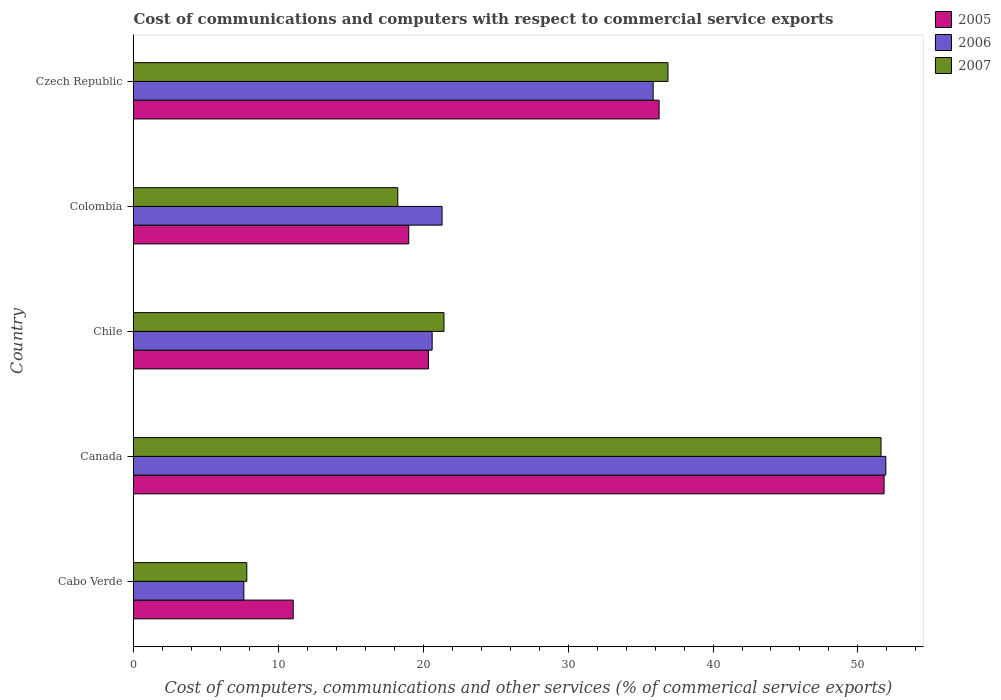How many groups of bars are there?
Offer a terse response. 5. Are the number of bars per tick equal to the number of legend labels?
Your answer should be compact. Yes. Are the number of bars on each tick of the Y-axis equal?
Your response must be concise. Yes. How many bars are there on the 4th tick from the top?
Offer a terse response. 3. How many bars are there on the 2nd tick from the bottom?
Your response must be concise. 3. In how many cases, is the number of bars for a given country not equal to the number of legend labels?
Provide a succinct answer. 0. What is the cost of communications and computers in 2006 in Chile?
Ensure brevity in your answer.  20.61. Across all countries, what is the maximum cost of communications and computers in 2005?
Your answer should be compact. 51.81. Across all countries, what is the minimum cost of communications and computers in 2007?
Offer a very short reply. 7.82. In which country was the cost of communications and computers in 2007 minimum?
Ensure brevity in your answer.  Cabo Verde. What is the total cost of communications and computers in 2005 in the graph?
Offer a terse response. 138.47. What is the difference between the cost of communications and computers in 2005 in Canada and that in Czech Republic?
Provide a succinct answer. 15.53. What is the difference between the cost of communications and computers in 2007 in Chile and the cost of communications and computers in 2005 in Cabo Verde?
Provide a short and direct response. 10.4. What is the average cost of communications and computers in 2005 per country?
Keep it short and to the point. 27.69. What is the difference between the cost of communications and computers in 2006 and cost of communications and computers in 2005 in Colombia?
Your answer should be very brief. 2.3. What is the ratio of the cost of communications and computers in 2007 in Cabo Verde to that in Chile?
Your response must be concise. 0.36. Is the cost of communications and computers in 2005 in Canada less than that in Czech Republic?
Offer a very short reply. No. What is the difference between the highest and the second highest cost of communications and computers in 2007?
Provide a succinct answer. 14.71. What is the difference between the highest and the lowest cost of communications and computers in 2005?
Make the answer very short. 40.78. In how many countries, is the cost of communications and computers in 2006 greater than the average cost of communications and computers in 2006 taken over all countries?
Your answer should be compact. 2. How many bars are there?
Offer a terse response. 15. Are the values on the major ticks of X-axis written in scientific E-notation?
Make the answer very short. No. Does the graph contain any zero values?
Your answer should be very brief. No. Where does the legend appear in the graph?
Ensure brevity in your answer.  Top right. How many legend labels are there?
Ensure brevity in your answer.  3. What is the title of the graph?
Offer a very short reply. Cost of communications and computers with respect to commercial service exports. What is the label or title of the X-axis?
Ensure brevity in your answer.  Cost of computers, communications and other services (% of commerical service exports). What is the Cost of computers, communications and other services (% of commerical service exports) in 2005 in Cabo Verde?
Give a very brief answer. 11.02. What is the Cost of computers, communications and other services (% of commerical service exports) in 2006 in Cabo Verde?
Provide a short and direct response. 7.62. What is the Cost of computers, communications and other services (% of commerical service exports) of 2007 in Cabo Verde?
Keep it short and to the point. 7.82. What is the Cost of computers, communications and other services (% of commerical service exports) of 2005 in Canada?
Give a very brief answer. 51.81. What is the Cost of computers, communications and other services (% of commerical service exports) in 2006 in Canada?
Provide a short and direct response. 51.93. What is the Cost of computers, communications and other services (% of commerical service exports) in 2007 in Canada?
Your answer should be compact. 51.6. What is the Cost of computers, communications and other services (% of commerical service exports) in 2005 in Chile?
Your response must be concise. 20.36. What is the Cost of computers, communications and other services (% of commerical service exports) in 2006 in Chile?
Offer a terse response. 20.61. What is the Cost of computers, communications and other services (% of commerical service exports) of 2007 in Chile?
Your answer should be compact. 21.43. What is the Cost of computers, communications and other services (% of commerical service exports) of 2005 in Colombia?
Your answer should be compact. 19. What is the Cost of computers, communications and other services (% of commerical service exports) of 2006 in Colombia?
Your answer should be compact. 21.3. What is the Cost of computers, communications and other services (% of commerical service exports) of 2007 in Colombia?
Your response must be concise. 18.24. What is the Cost of computers, communications and other services (% of commerical service exports) in 2005 in Czech Republic?
Your answer should be very brief. 36.28. What is the Cost of computers, communications and other services (% of commerical service exports) in 2006 in Czech Republic?
Provide a short and direct response. 35.87. What is the Cost of computers, communications and other services (% of commerical service exports) of 2007 in Czech Republic?
Keep it short and to the point. 36.89. Across all countries, what is the maximum Cost of computers, communications and other services (% of commerical service exports) in 2005?
Offer a terse response. 51.81. Across all countries, what is the maximum Cost of computers, communications and other services (% of commerical service exports) in 2006?
Provide a short and direct response. 51.93. Across all countries, what is the maximum Cost of computers, communications and other services (% of commerical service exports) in 2007?
Offer a terse response. 51.6. Across all countries, what is the minimum Cost of computers, communications and other services (% of commerical service exports) in 2005?
Ensure brevity in your answer.  11.02. Across all countries, what is the minimum Cost of computers, communications and other services (% of commerical service exports) of 2006?
Make the answer very short. 7.62. Across all countries, what is the minimum Cost of computers, communications and other services (% of commerical service exports) in 2007?
Your answer should be compact. 7.82. What is the total Cost of computers, communications and other services (% of commerical service exports) of 2005 in the graph?
Your answer should be compact. 138.47. What is the total Cost of computers, communications and other services (% of commerical service exports) in 2006 in the graph?
Give a very brief answer. 137.32. What is the total Cost of computers, communications and other services (% of commerical service exports) in 2007 in the graph?
Your answer should be very brief. 135.97. What is the difference between the Cost of computers, communications and other services (% of commerical service exports) of 2005 in Cabo Verde and that in Canada?
Ensure brevity in your answer.  -40.78. What is the difference between the Cost of computers, communications and other services (% of commerical service exports) in 2006 in Cabo Verde and that in Canada?
Your answer should be very brief. -44.31. What is the difference between the Cost of computers, communications and other services (% of commerical service exports) in 2007 in Cabo Verde and that in Canada?
Keep it short and to the point. -43.78. What is the difference between the Cost of computers, communications and other services (% of commerical service exports) of 2005 in Cabo Verde and that in Chile?
Keep it short and to the point. -9.33. What is the difference between the Cost of computers, communications and other services (% of commerical service exports) of 2006 in Cabo Verde and that in Chile?
Your answer should be compact. -13. What is the difference between the Cost of computers, communications and other services (% of commerical service exports) of 2007 in Cabo Verde and that in Chile?
Your answer should be very brief. -13.61. What is the difference between the Cost of computers, communications and other services (% of commerical service exports) of 2005 in Cabo Verde and that in Colombia?
Give a very brief answer. -7.97. What is the difference between the Cost of computers, communications and other services (% of commerical service exports) of 2006 in Cabo Verde and that in Colombia?
Offer a terse response. -13.68. What is the difference between the Cost of computers, communications and other services (% of commerical service exports) of 2007 in Cabo Verde and that in Colombia?
Offer a very short reply. -10.42. What is the difference between the Cost of computers, communications and other services (% of commerical service exports) in 2005 in Cabo Verde and that in Czech Republic?
Offer a very short reply. -25.25. What is the difference between the Cost of computers, communications and other services (% of commerical service exports) in 2006 in Cabo Verde and that in Czech Republic?
Keep it short and to the point. -28.25. What is the difference between the Cost of computers, communications and other services (% of commerical service exports) of 2007 in Cabo Verde and that in Czech Republic?
Give a very brief answer. -29.07. What is the difference between the Cost of computers, communications and other services (% of commerical service exports) in 2005 in Canada and that in Chile?
Provide a succinct answer. 31.45. What is the difference between the Cost of computers, communications and other services (% of commerical service exports) of 2006 in Canada and that in Chile?
Offer a very short reply. 31.31. What is the difference between the Cost of computers, communications and other services (% of commerical service exports) in 2007 in Canada and that in Chile?
Ensure brevity in your answer.  30.17. What is the difference between the Cost of computers, communications and other services (% of commerical service exports) of 2005 in Canada and that in Colombia?
Ensure brevity in your answer.  32.81. What is the difference between the Cost of computers, communications and other services (% of commerical service exports) in 2006 in Canada and that in Colombia?
Your answer should be very brief. 30.63. What is the difference between the Cost of computers, communications and other services (% of commerical service exports) in 2007 in Canada and that in Colombia?
Provide a succinct answer. 33.36. What is the difference between the Cost of computers, communications and other services (% of commerical service exports) of 2005 in Canada and that in Czech Republic?
Give a very brief answer. 15.53. What is the difference between the Cost of computers, communications and other services (% of commerical service exports) of 2006 in Canada and that in Czech Republic?
Your response must be concise. 16.06. What is the difference between the Cost of computers, communications and other services (% of commerical service exports) of 2007 in Canada and that in Czech Republic?
Ensure brevity in your answer.  14.71. What is the difference between the Cost of computers, communications and other services (% of commerical service exports) in 2005 in Chile and that in Colombia?
Give a very brief answer. 1.36. What is the difference between the Cost of computers, communications and other services (% of commerical service exports) of 2006 in Chile and that in Colombia?
Your response must be concise. -0.69. What is the difference between the Cost of computers, communications and other services (% of commerical service exports) in 2007 in Chile and that in Colombia?
Provide a short and direct response. 3.19. What is the difference between the Cost of computers, communications and other services (% of commerical service exports) of 2005 in Chile and that in Czech Republic?
Give a very brief answer. -15.92. What is the difference between the Cost of computers, communications and other services (% of commerical service exports) in 2006 in Chile and that in Czech Republic?
Offer a very short reply. -15.25. What is the difference between the Cost of computers, communications and other services (% of commerical service exports) in 2007 in Chile and that in Czech Republic?
Give a very brief answer. -15.46. What is the difference between the Cost of computers, communications and other services (% of commerical service exports) in 2005 in Colombia and that in Czech Republic?
Your answer should be very brief. -17.28. What is the difference between the Cost of computers, communications and other services (% of commerical service exports) in 2006 in Colombia and that in Czech Republic?
Your response must be concise. -14.57. What is the difference between the Cost of computers, communications and other services (% of commerical service exports) in 2007 in Colombia and that in Czech Republic?
Offer a terse response. -18.65. What is the difference between the Cost of computers, communications and other services (% of commerical service exports) in 2005 in Cabo Verde and the Cost of computers, communications and other services (% of commerical service exports) in 2006 in Canada?
Your response must be concise. -40.9. What is the difference between the Cost of computers, communications and other services (% of commerical service exports) of 2005 in Cabo Verde and the Cost of computers, communications and other services (% of commerical service exports) of 2007 in Canada?
Make the answer very short. -40.57. What is the difference between the Cost of computers, communications and other services (% of commerical service exports) in 2006 in Cabo Verde and the Cost of computers, communications and other services (% of commerical service exports) in 2007 in Canada?
Your answer should be compact. -43.98. What is the difference between the Cost of computers, communications and other services (% of commerical service exports) of 2005 in Cabo Verde and the Cost of computers, communications and other services (% of commerical service exports) of 2006 in Chile?
Provide a succinct answer. -9.59. What is the difference between the Cost of computers, communications and other services (% of commerical service exports) in 2005 in Cabo Verde and the Cost of computers, communications and other services (% of commerical service exports) in 2007 in Chile?
Provide a succinct answer. -10.4. What is the difference between the Cost of computers, communications and other services (% of commerical service exports) of 2006 in Cabo Verde and the Cost of computers, communications and other services (% of commerical service exports) of 2007 in Chile?
Keep it short and to the point. -13.81. What is the difference between the Cost of computers, communications and other services (% of commerical service exports) of 2005 in Cabo Verde and the Cost of computers, communications and other services (% of commerical service exports) of 2006 in Colombia?
Offer a very short reply. -10.27. What is the difference between the Cost of computers, communications and other services (% of commerical service exports) in 2005 in Cabo Verde and the Cost of computers, communications and other services (% of commerical service exports) in 2007 in Colombia?
Offer a very short reply. -7.22. What is the difference between the Cost of computers, communications and other services (% of commerical service exports) of 2006 in Cabo Verde and the Cost of computers, communications and other services (% of commerical service exports) of 2007 in Colombia?
Your answer should be very brief. -10.62. What is the difference between the Cost of computers, communications and other services (% of commerical service exports) in 2005 in Cabo Verde and the Cost of computers, communications and other services (% of commerical service exports) in 2006 in Czech Republic?
Ensure brevity in your answer.  -24.84. What is the difference between the Cost of computers, communications and other services (% of commerical service exports) in 2005 in Cabo Verde and the Cost of computers, communications and other services (% of commerical service exports) in 2007 in Czech Republic?
Offer a terse response. -25.86. What is the difference between the Cost of computers, communications and other services (% of commerical service exports) in 2006 in Cabo Verde and the Cost of computers, communications and other services (% of commerical service exports) in 2007 in Czech Republic?
Your answer should be compact. -29.27. What is the difference between the Cost of computers, communications and other services (% of commerical service exports) in 2005 in Canada and the Cost of computers, communications and other services (% of commerical service exports) in 2006 in Chile?
Provide a succinct answer. 31.19. What is the difference between the Cost of computers, communications and other services (% of commerical service exports) of 2005 in Canada and the Cost of computers, communications and other services (% of commerical service exports) of 2007 in Chile?
Ensure brevity in your answer.  30.38. What is the difference between the Cost of computers, communications and other services (% of commerical service exports) in 2006 in Canada and the Cost of computers, communications and other services (% of commerical service exports) in 2007 in Chile?
Offer a terse response. 30.5. What is the difference between the Cost of computers, communications and other services (% of commerical service exports) in 2005 in Canada and the Cost of computers, communications and other services (% of commerical service exports) in 2006 in Colombia?
Provide a short and direct response. 30.51. What is the difference between the Cost of computers, communications and other services (% of commerical service exports) of 2005 in Canada and the Cost of computers, communications and other services (% of commerical service exports) of 2007 in Colombia?
Provide a short and direct response. 33.57. What is the difference between the Cost of computers, communications and other services (% of commerical service exports) of 2006 in Canada and the Cost of computers, communications and other services (% of commerical service exports) of 2007 in Colombia?
Your answer should be very brief. 33.69. What is the difference between the Cost of computers, communications and other services (% of commerical service exports) of 2005 in Canada and the Cost of computers, communications and other services (% of commerical service exports) of 2006 in Czech Republic?
Your answer should be compact. 15.94. What is the difference between the Cost of computers, communications and other services (% of commerical service exports) of 2005 in Canada and the Cost of computers, communications and other services (% of commerical service exports) of 2007 in Czech Republic?
Your answer should be very brief. 14.92. What is the difference between the Cost of computers, communications and other services (% of commerical service exports) in 2006 in Canada and the Cost of computers, communications and other services (% of commerical service exports) in 2007 in Czech Republic?
Make the answer very short. 15.04. What is the difference between the Cost of computers, communications and other services (% of commerical service exports) in 2005 in Chile and the Cost of computers, communications and other services (% of commerical service exports) in 2006 in Colombia?
Make the answer very short. -0.94. What is the difference between the Cost of computers, communications and other services (% of commerical service exports) in 2005 in Chile and the Cost of computers, communications and other services (% of commerical service exports) in 2007 in Colombia?
Your answer should be very brief. 2.12. What is the difference between the Cost of computers, communications and other services (% of commerical service exports) in 2006 in Chile and the Cost of computers, communications and other services (% of commerical service exports) in 2007 in Colombia?
Provide a succinct answer. 2.37. What is the difference between the Cost of computers, communications and other services (% of commerical service exports) in 2005 in Chile and the Cost of computers, communications and other services (% of commerical service exports) in 2006 in Czech Republic?
Keep it short and to the point. -15.51. What is the difference between the Cost of computers, communications and other services (% of commerical service exports) in 2005 in Chile and the Cost of computers, communications and other services (% of commerical service exports) in 2007 in Czech Republic?
Offer a terse response. -16.53. What is the difference between the Cost of computers, communications and other services (% of commerical service exports) of 2006 in Chile and the Cost of computers, communications and other services (% of commerical service exports) of 2007 in Czech Republic?
Make the answer very short. -16.27. What is the difference between the Cost of computers, communications and other services (% of commerical service exports) of 2005 in Colombia and the Cost of computers, communications and other services (% of commerical service exports) of 2006 in Czech Republic?
Your answer should be compact. -16.87. What is the difference between the Cost of computers, communications and other services (% of commerical service exports) in 2005 in Colombia and the Cost of computers, communications and other services (% of commerical service exports) in 2007 in Czech Republic?
Your answer should be very brief. -17.89. What is the difference between the Cost of computers, communications and other services (% of commerical service exports) in 2006 in Colombia and the Cost of computers, communications and other services (% of commerical service exports) in 2007 in Czech Republic?
Provide a succinct answer. -15.59. What is the average Cost of computers, communications and other services (% of commerical service exports) of 2005 per country?
Your response must be concise. 27.69. What is the average Cost of computers, communications and other services (% of commerical service exports) of 2006 per country?
Provide a short and direct response. 27.46. What is the average Cost of computers, communications and other services (% of commerical service exports) of 2007 per country?
Your answer should be very brief. 27.19. What is the difference between the Cost of computers, communications and other services (% of commerical service exports) of 2005 and Cost of computers, communications and other services (% of commerical service exports) of 2006 in Cabo Verde?
Give a very brief answer. 3.41. What is the difference between the Cost of computers, communications and other services (% of commerical service exports) in 2005 and Cost of computers, communications and other services (% of commerical service exports) in 2007 in Cabo Verde?
Offer a terse response. 3.21. What is the difference between the Cost of computers, communications and other services (% of commerical service exports) of 2006 and Cost of computers, communications and other services (% of commerical service exports) of 2007 in Cabo Verde?
Provide a succinct answer. -0.2. What is the difference between the Cost of computers, communications and other services (% of commerical service exports) in 2005 and Cost of computers, communications and other services (% of commerical service exports) in 2006 in Canada?
Offer a very short reply. -0.12. What is the difference between the Cost of computers, communications and other services (% of commerical service exports) in 2005 and Cost of computers, communications and other services (% of commerical service exports) in 2007 in Canada?
Make the answer very short. 0.21. What is the difference between the Cost of computers, communications and other services (% of commerical service exports) in 2006 and Cost of computers, communications and other services (% of commerical service exports) in 2007 in Canada?
Your answer should be very brief. 0.33. What is the difference between the Cost of computers, communications and other services (% of commerical service exports) in 2005 and Cost of computers, communications and other services (% of commerical service exports) in 2006 in Chile?
Give a very brief answer. -0.26. What is the difference between the Cost of computers, communications and other services (% of commerical service exports) of 2005 and Cost of computers, communications and other services (% of commerical service exports) of 2007 in Chile?
Provide a short and direct response. -1.07. What is the difference between the Cost of computers, communications and other services (% of commerical service exports) in 2006 and Cost of computers, communications and other services (% of commerical service exports) in 2007 in Chile?
Provide a succinct answer. -0.81. What is the difference between the Cost of computers, communications and other services (% of commerical service exports) of 2005 and Cost of computers, communications and other services (% of commerical service exports) of 2006 in Colombia?
Your answer should be very brief. -2.3. What is the difference between the Cost of computers, communications and other services (% of commerical service exports) of 2005 and Cost of computers, communications and other services (% of commerical service exports) of 2007 in Colombia?
Ensure brevity in your answer.  0.76. What is the difference between the Cost of computers, communications and other services (% of commerical service exports) in 2006 and Cost of computers, communications and other services (% of commerical service exports) in 2007 in Colombia?
Your answer should be very brief. 3.06. What is the difference between the Cost of computers, communications and other services (% of commerical service exports) of 2005 and Cost of computers, communications and other services (% of commerical service exports) of 2006 in Czech Republic?
Keep it short and to the point. 0.41. What is the difference between the Cost of computers, communications and other services (% of commerical service exports) of 2005 and Cost of computers, communications and other services (% of commerical service exports) of 2007 in Czech Republic?
Keep it short and to the point. -0.61. What is the difference between the Cost of computers, communications and other services (% of commerical service exports) of 2006 and Cost of computers, communications and other services (% of commerical service exports) of 2007 in Czech Republic?
Provide a short and direct response. -1.02. What is the ratio of the Cost of computers, communications and other services (% of commerical service exports) in 2005 in Cabo Verde to that in Canada?
Keep it short and to the point. 0.21. What is the ratio of the Cost of computers, communications and other services (% of commerical service exports) in 2006 in Cabo Verde to that in Canada?
Keep it short and to the point. 0.15. What is the ratio of the Cost of computers, communications and other services (% of commerical service exports) in 2007 in Cabo Verde to that in Canada?
Offer a terse response. 0.15. What is the ratio of the Cost of computers, communications and other services (% of commerical service exports) of 2005 in Cabo Verde to that in Chile?
Keep it short and to the point. 0.54. What is the ratio of the Cost of computers, communications and other services (% of commerical service exports) in 2006 in Cabo Verde to that in Chile?
Keep it short and to the point. 0.37. What is the ratio of the Cost of computers, communications and other services (% of commerical service exports) in 2007 in Cabo Verde to that in Chile?
Keep it short and to the point. 0.36. What is the ratio of the Cost of computers, communications and other services (% of commerical service exports) of 2005 in Cabo Verde to that in Colombia?
Make the answer very short. 0.58. What is the ratio of the Cost of computers, communications and other services (% of commerical service exports) in 2006 in Cabo Verde to that in Colombia?
Ensure brevity in your answer.  0.36. What is the ratio of the Cost of computers, communications and other services (% of commerical service exports) of 2007 in Cabo Verde to that in Colombia?
Give a very brief answer. 0.43. What is the ratio of the Cost of computers, communications and other services (% of commerical service exports) in 2005 in Cabo Verde to that in Czech Republic?
Provide a short and direct response. 0.3. What is the ratio of the Cost of computers, communications and other services (% of commerical service exports) of 2006 in Cabo Verde to that in Czech Republic?
Make the answer very short. 0.21. What is the ratio of the Cost of computers, communications and other services (% of commerical service exports) in 2007 in Cabo Verde to that in Czech Republic?
Give a very brief answer. 0.21. What is the ratio of the Cost of computers, communications and other services (% of commerical service exports) in 2005 in Canada to that in Chile?
Your response must be concise. 2.54. What is the ratio of the Cost of computers, communications and other services (% of commerical service exports) in 2006 in Canada to that in Chile?
Your response must be concise. 2.52. What is the ratio of the Cost of computers, communications and other services (% of commerical service exports) of 2007 in Canada to that in Chile?
Give a very brief answer. 2.41. What is the ratio of the Cost of computers, communications and other services (% of commerical service exports) in 2005 in Canada to that in Colombia?
Keep it short and to the point. 2.73. What is the ratio of the Cost of computers, communications and other services (% of commerical service exports) in 2006 in Canada to that in Colombia?
Your response must be concise. 2.44. What is the ratio of the Cost of computers, communications and other services (% of commerical service exports) in 2007 in Canada to that in Colombia?
Make the answer very short. 2.83. What is the ratio of the Cost of computers, communications and other services (% of commerical service exports) in 2005 in Canada to that in Czech Republic?
Give a very brief answer. 1.43. What is the ratio of the Cost of computers, communications and other services (% of commerical service exports) in 2006 in Canada to that in Czech Republic?
Offer a very short reply. 1.45. What is the ratio of the Cost of computers, communications and other services (% of commerical service exports) of 2007 in Canada to that in Czech Republic?
Your response must be concise. 1.4. What is the ratio of the Cost of computers, communications and other services (% of commerical service exports) of 2005 in Chile to that in Colombia?
Your answer should be very brief. 1.07. What is the ratio of the Cost of computers, communications and other services (% of commerical service exports) of 2006 in Chile to that in Colombia?
Provide a short and direct response. 0.97. What is the ratio of the Cost of computers, communications and other services (% of commerical service exports) in 2007 in Chile to that in Colombia?
Your response must be concise. 1.17. What is the ratio of the Cost of computers, communications and other services (% of commerical service exports) in 2005 in Chile to that in Czech Republic?
Your answer should be very brief. 0.56. What is the ratio of the Cost of computers, communications and other services (% of commerical service exports) of 2006 in Chile to that in Czech Republic?
Offer a terse response. 0.57. What is the ratio of the Cost of computers, communications and other services (% of commerical service exports) in 2007 in Chile to that in Czech Republic?
Keep it short and to the point. 0.58. What is the ratio of the Cost of computers, communications and other services (% of commerical service exports) of 2005 in Colombia to that in Czech Republic?
Your response must be concise. 0.52. What is the ratio of the Cost of computers, communications and other services (% of commerical service exports) in 2006 in Colombia to that in Czech Republic?
Provide a short and direct response. 0.59. What is the ratio of the Cost of computers, communications and other services (% of commerical service exports) in 2007 in Colombia to that in Czech Republic?
Your response must be concise. 0.49. What is the difference between the highest and the second highest Cost of computers, communications and other services (% of commerical service exports) of 2005?
Make the answer very short. 15.53. What is the difference between the highest and the second highest Cost of computers, communications and other services (% of commerical service exports) in 2006?
Give a very brief answer. 16.06. What is the difference between the highest and the second highest Cost of computers, communications and other services (% of commerical service exports) in 2007?
Ensure brevity in your answer.  14.71. What is the difference between the highest and the lowest Cost of computers, communications and other services (% of commerical service exports) in 2005?
Give a very brief answer. 40.78. What is the difference between the highest and the lowest Cost of computers, communications and other services (% of commerical service exports) in 2006?
Your answer should be very brief. 44.31. What is the difference between the highest and the lowest Cost of computers, communications and other services (% of commerical service exports) of 2007?
Your answer should be very brief. 43.78. 